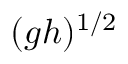<formula> <loc_0><loc_0><loc_500><loc_500>( g h ) ^ { 1 / 2 }</formula> 